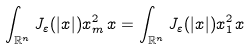Convert formula to latex. <formula><loc_0><loc_0><loc_500><loc_500>\int _ { \mathbb { R } ^ { n } } J _ { \varepsilon } ( | x | ) x _ { m } ^ { 2 } \, x = \int _ { \mathbb { R } ^ { n } } J _ { \varepsilon } ( | x | ) x _ { 1 } ^ { 2 } \, x</formula> 